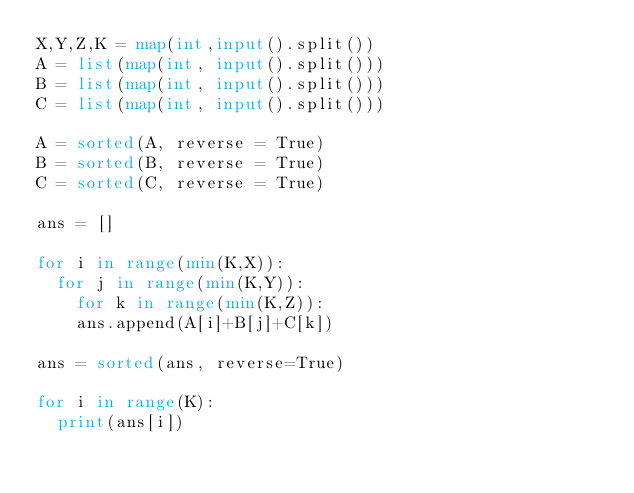<code> <loc_0><loc_0><loc_500><loc_500><_Python_>X,Y,Z,K = map(int,input().split())
A = list(map(int, input().split()))
B = list(map(int, input().split()))
C = list(map(int, input().split()))

A = sorted(A, reverse = True)
B = sorted(B, reverse = True)
C = sorted(C, reverse = True)

ans = []

for i in range(min(K,X)):
  for j in range(min(K,Y)):
    for k in range(min(K,Z)):
    ans.append(A[i]+B[j]+C[k])
    
ans = sorted(ans, reverse=True)

for i in range(K):
  print(ans[i])
      
</code> 